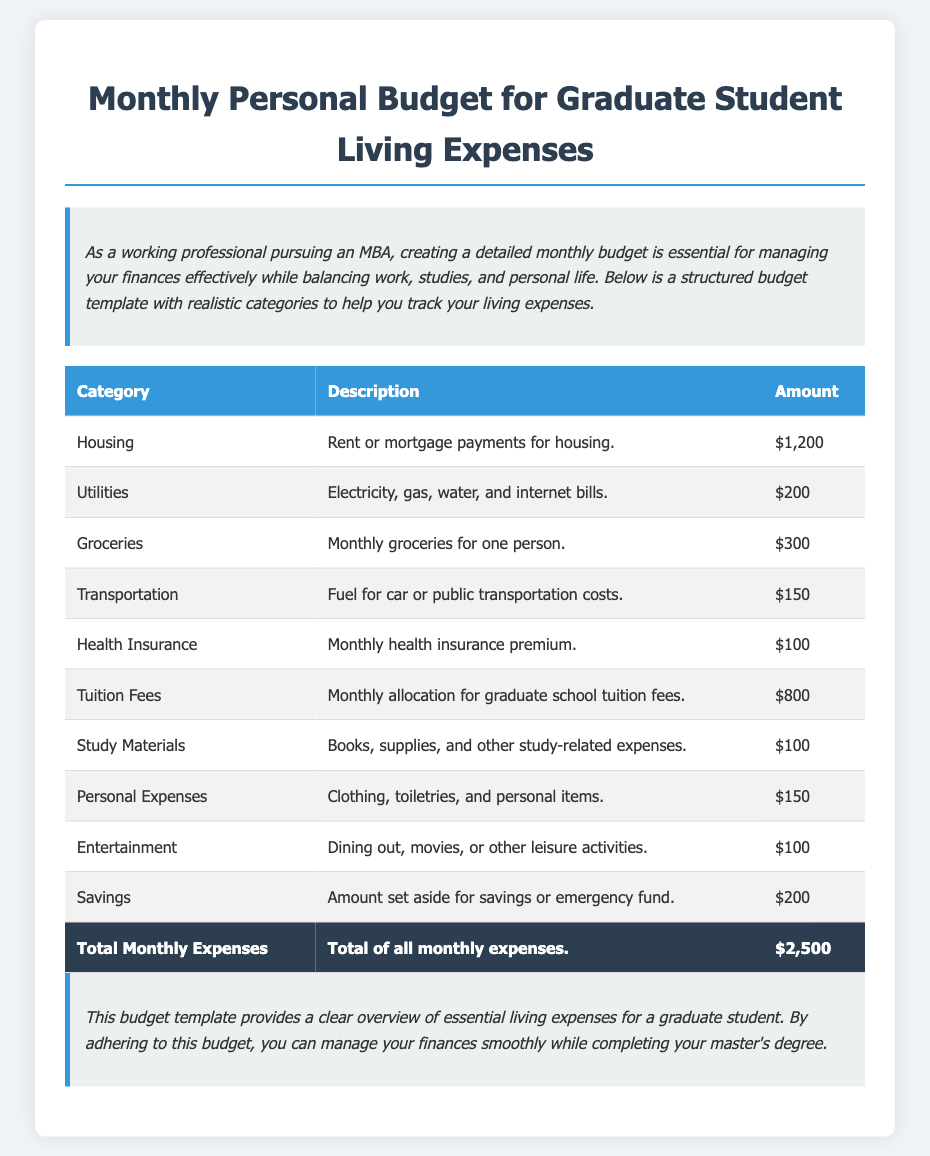What is the total monthly expense? The total monthly expense is calculated by summing all individual categories listed in the budget, which equals $2,500.
Answer: $2,500 How much is allocated for tuition fees? The tuition fees category specifies the monthly allocation for graduate school tuition fees, which is stated in the document.
Answer: $800 What is the budget amount for groceries? The budget specifies the amount allocated for monthly groceries for one person, which is detailed in the cost breakdown.
Answer: $300 What are personal expenses in the budget? The personal expenses category includes clothing, toiletries, and other personal items outlined in the document.
Answer: $150 How much is set aside for savings? The budget includes a specific amount earmarked for savings or an emergency fund, which can be found in the respective category in the table.
Answer: $200 What is the amount for utilities? The utilities category includes the costs for electricity, gas, water, and internet bills and is specified directly in the document.
Answer: $200 How many categories are listed in the budget? The budget table contains various categories that are essential for tracking monthly living expenses, which can be counted from the table.
Answer: 10 What type of document is this? This document serves as a personal budgeting guide tailored for graduate students to help manage living expenses effectively.
Answer: Budget Template 